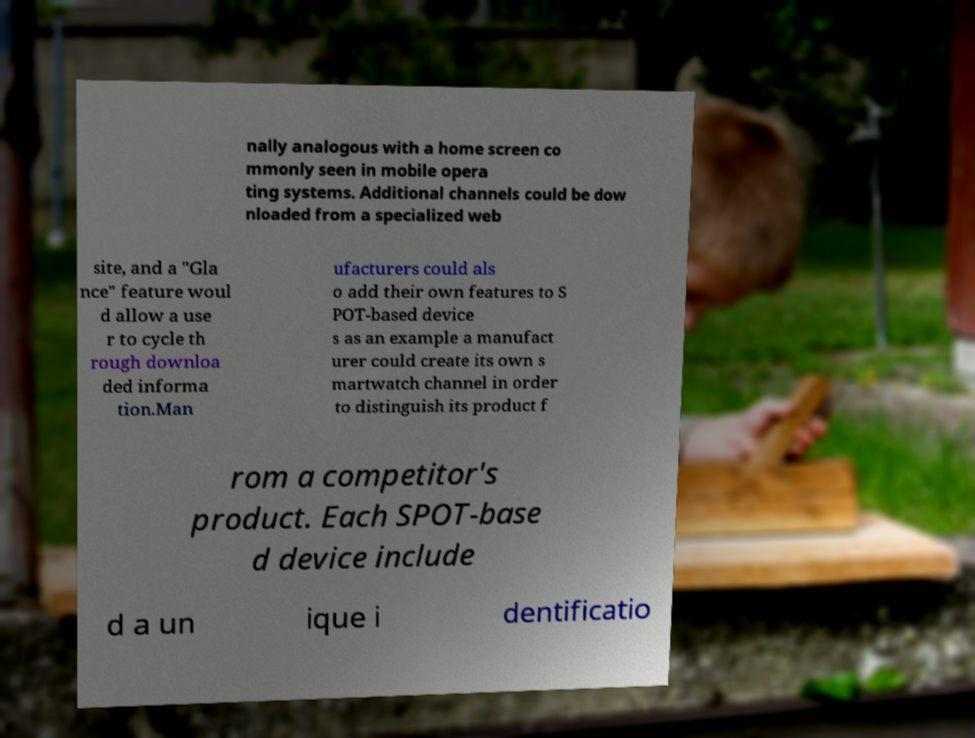Please read and relay the text visible in this image. What does it say? nally analogous with a home screen co mmonly seen in mobile opera ting systems. Additional channels could be dow nloaded from a specialized web site, and a "Gla nce" feature woul d allow a use r to cycle th rough downloa ded informa tion.Man ufacturers could als o add their own features to S POT-based device s as an example a manufact urer could create its own s martwatch channel in order to distinguish its product f rom a competitor's product. Each SPOT-base d device include d a un ique i dentificatio 